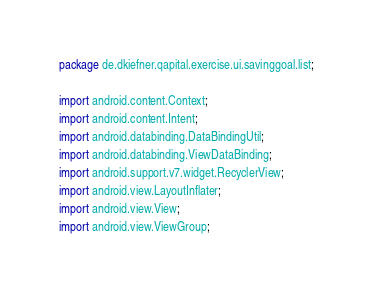Convert code to text. <code><loc_0><loc_0><loc_500><loc_500><_Java_>package de.dkiefner.qapital.exercise.ui.savinggoal.list;

import android.content.Context;
import android.content.Intent;
import android.databinding.DataBindingUtil;
import android.databinding.ViewDataBinding;
import android.support.v7.widget.RecyclerView;
import android.view.LayoutInflater;
import android.view.View;
import android.view.ViewGroup;
</code> 